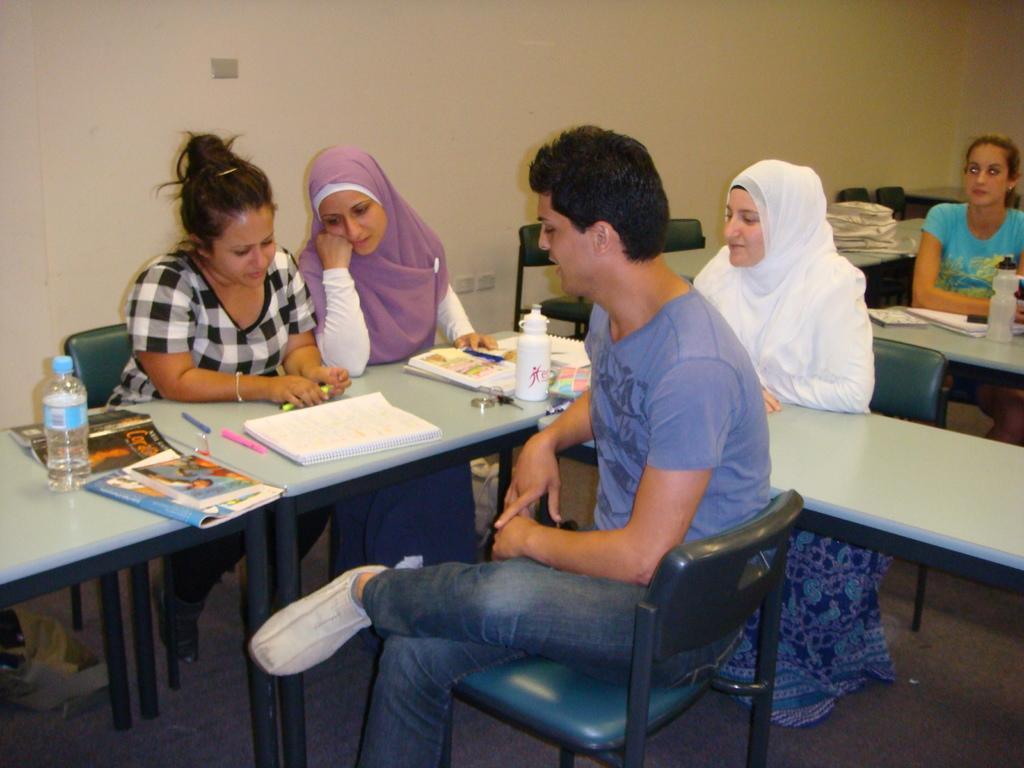Please provide a concise description of this image. This persons are sitting on a chair. In-front of this person there are tables. On table there are bottles, books, pens and papers. This woman wore white scarf. This woman wore purple scarf. 